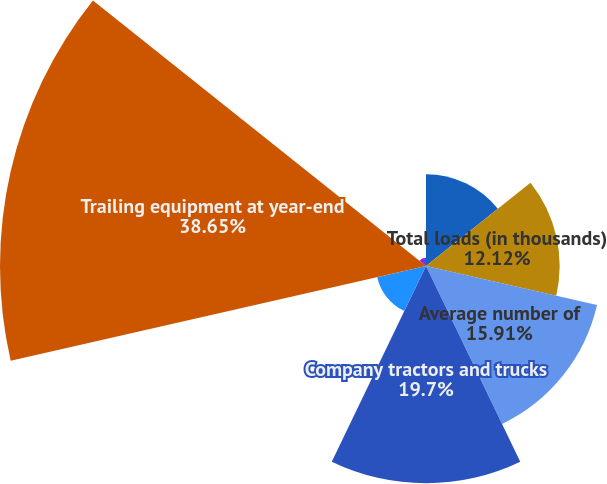<chart> <loc_0><loc_0><loc_500><loc_500><pie_chart><fcel>Operating data for the years<fcel>Total loads (in thousands)<fcel>Average number of<fcel>Company tractors and trucks<fcel>Independent contractors at<fcel>Trailing equipment at year-end<fcel>Company tractor miles (in<nl><fcel>8.33%<fcel>12.12%<fcel>15.91%<fcel>19.7%<fcel>4.54%<fcel>38.64%<fcel>0.75%<nl></chart> 